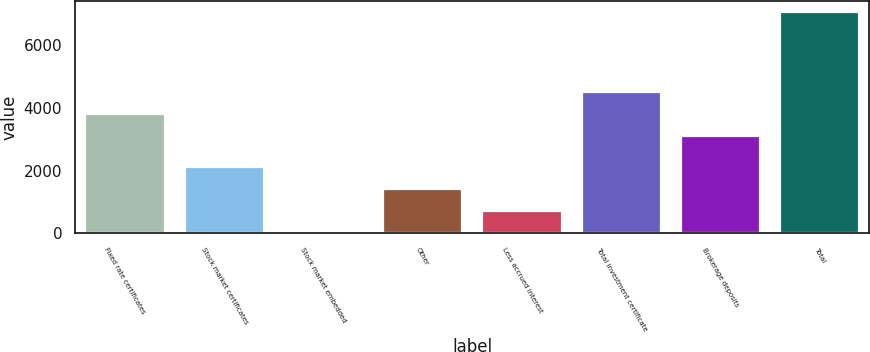Convert chart to OTSL. <chart><loc_0><loc_0><loc_500><loc_500><bar_chart><fcel>Fixed rate certificates<fcel>Stock market certificates<fcel>Stock market embedded<fcel>Other<fcel>Less accrued interest<fcel>Total investment certificate<fcel>Brokerage deposits<fcel>Total<nl><fcel>3793.5<fcel>2123.5<fcel>7<fcel>1418<fcel>712.5<fcel>4499<fcel>3088<fcel>7062<nl></chart> 